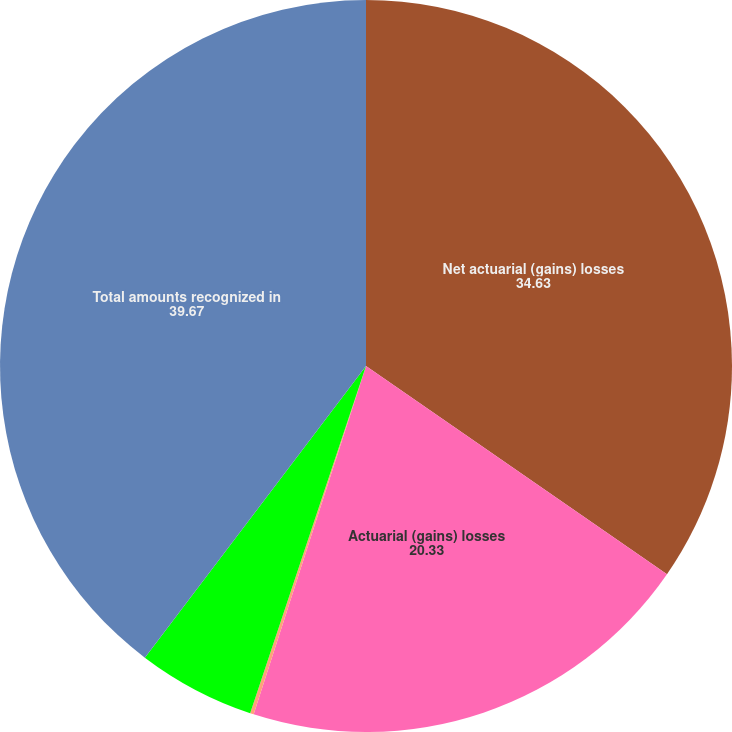Convert chart. <chart><loc_0><loc_0><loc_500><loc_500><pie_chart><fcel>Net actuarial (gains) losses<fcel>Actuarial (gains) losses<fcel>Amortization of amounts<fcel>Net prior service cost<fcel>Total amounts recognized in<nl><fcel>34.63%<fcel>20.33%<fcel>0.16%<fcel>5.2%<fcel>39.67%<nl></chart> 